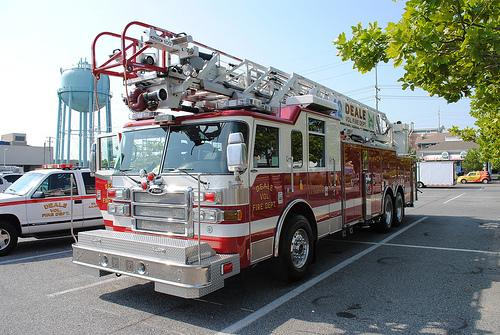What are some features on the fire truck ladder and what do the sirens look like? The fire truck ladder has red and silver rails, and the sirens are white and red in color. Identify the primary focus of the image and describe its characteristics. The main focus in the image is a red and white fire truck that is parked, occupying two parking spots, with details like a ladder, sirens, and orange lettering on the side. Provide a brief description of the setting where the main subject of the image is located. The fire truck is parked in a parking lot with delineated white lines, surrounded by other vehicles and objects like a large water tower, a portable white trailer, and a fire department vehicle. List three other objects or vehicles that are present in the parking lot along with the fire truck. A yellow and orange parked vehicle, a fire department vehicle with blue and red stripes, and a white trailer are present in the parking lot along with the fire truck. Describe the state of the fire truck's ladder and what color is the water tower in the image. The fire truck ladder is down and the water tower is large and green. 